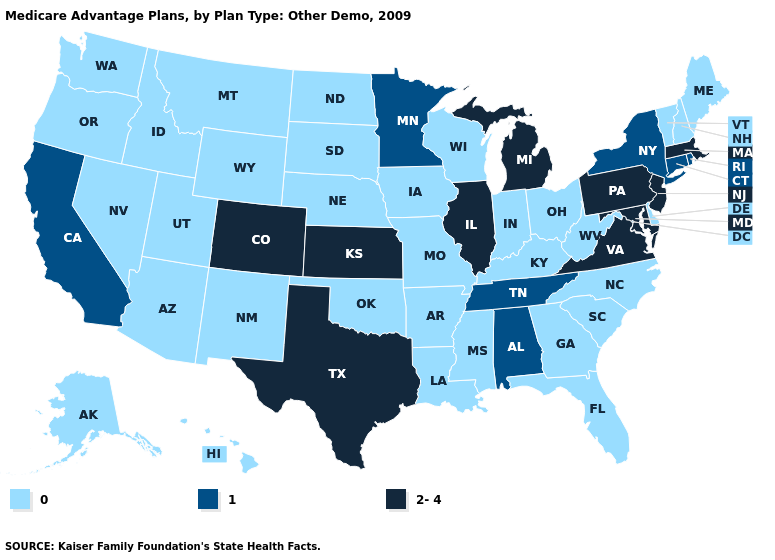What is the highest value in the USA?
Quick response, please. 2-4. What is the value of Rhode Island?
Concise answer only. 1. Does the map have missing data?
Be succinct. No. What is the lowest value in the South?
Short answer required. 0. Does Hawaii have the highest value in the USA?
Short answer required. No. Name the states that have a value in the range 1?
Answer briefly. Alabama, California, Connecticut, Minnesota, New York, Rhode Island, Tennessee. What is the lowest value in the Northeast?
Write a very short answer. 0. How many symbols are there in the legend?
Quick response, please. 3. Does Kansas have the highest value in the MidWest?
Be succinct. Yes. What is the value of Tennessee?
Give a very brief answer. 1. What is the lowest value in states that border Arkansas?
Write a very short answer. 0. Among the states that border North Dakota , does South Dakota have the highest value?
Short answer required. No. What is the value of Florida?
Write a very short answer. 0. Which states hav the highest value in the South?
Write a very short answer. Maryland, Texas, Virginia. Does the first symbol in the legend represent the smallest category?
Concise answer only. Yes. 